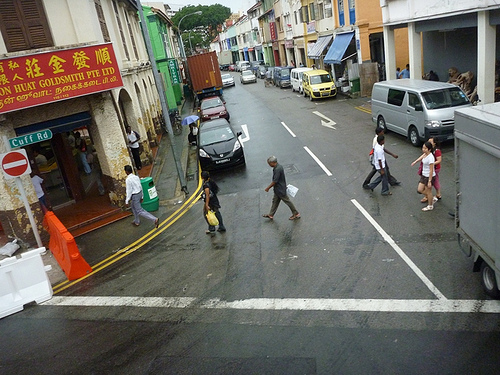<image>
Is the car next to the road? Yes. The car is positioned adjacent to the road, located nearby in the same general area. 